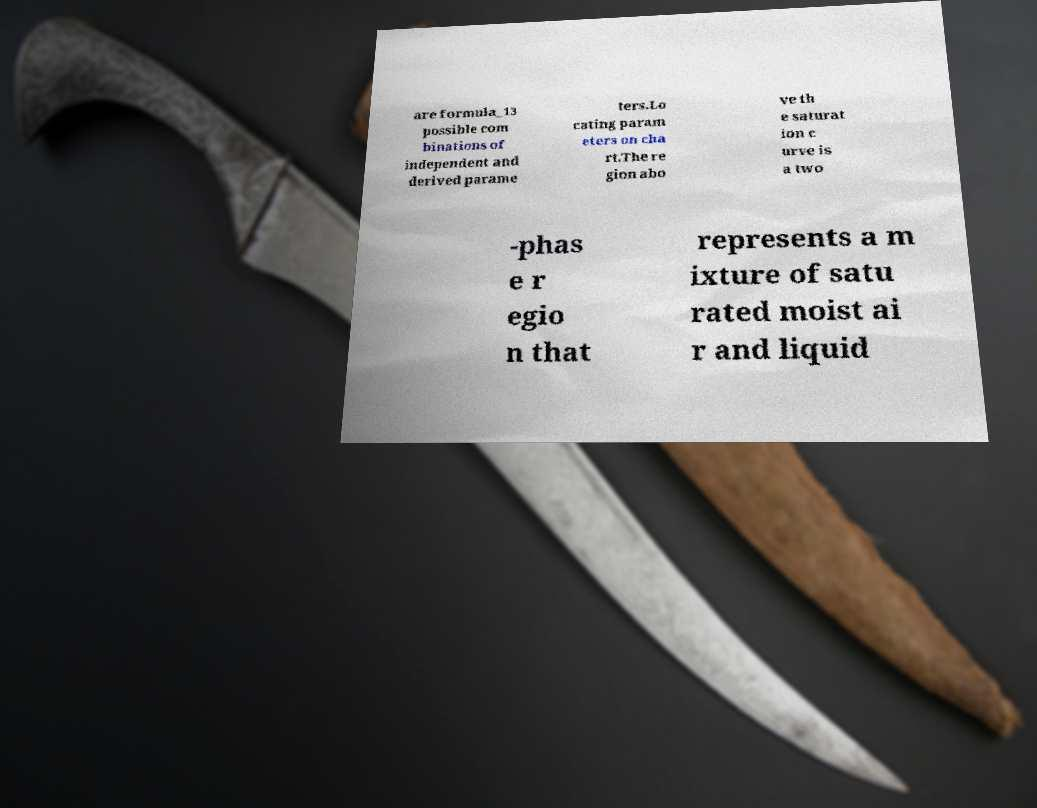Please read and relay the text visible in this image. What does it say? are formula_13 possible com binations of independent and derived parame ters.Lo cating param eters on cha rt.The re gion abo ve th e saturat ion c urve is a two -phas e r egio n that represents a m ixture of satu rated moist ai r and liquid 